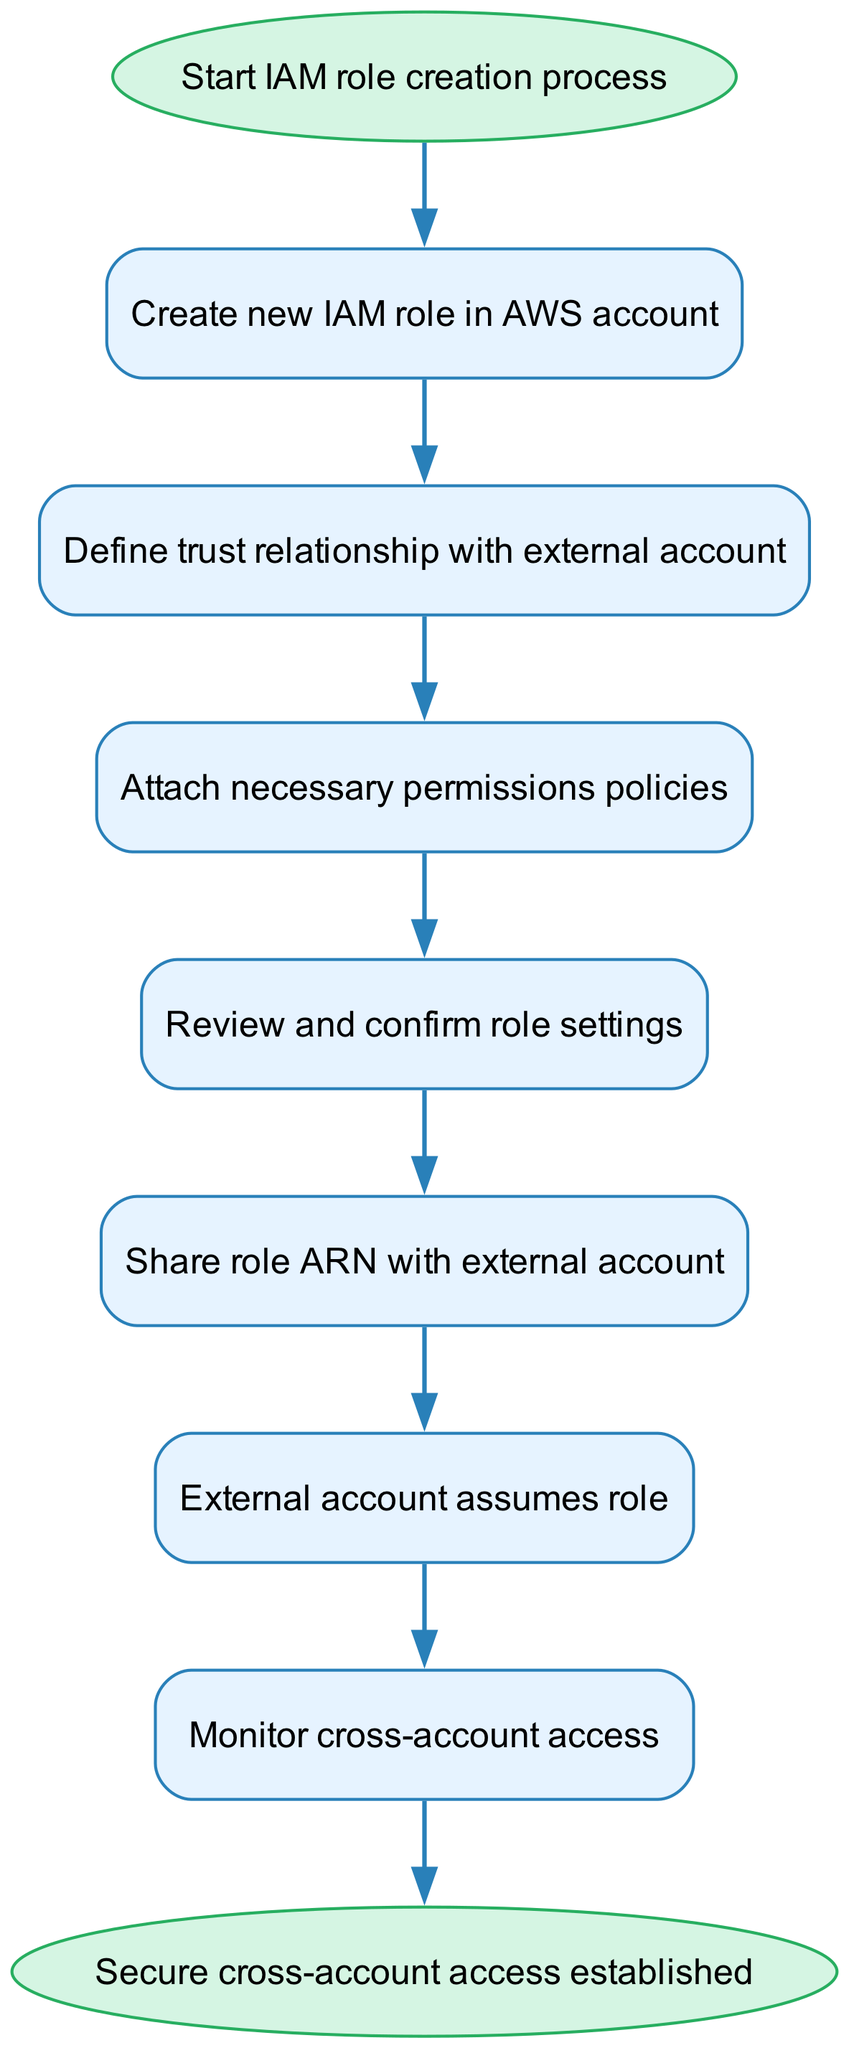What is the first step in the IAM role creation process? The first step is represented by the "Start IAM role creation process" node. It initiates the entire flow of the diagram until the last step.
Answer: Start IAM role creation process How many nodes are in this diagram? There are 9 nodes representing various steps in the IAM role creation process, including the start and end points.
Answer: 9 What step follows after attaching necessary permissions policies? The process moves to the "Review and confirm role settings" step immediately after "Attach necessary permissions policies".
Answer: Review and confirm role settings What is shared with the external account? The diagram indicates that the "role ARN" is shared with the external account after role settings have been confirmed.
Answer: role ARN Which step is completed before monitoring access? Before monitoring access, the "External account assumes role" step must be completed, indicating the external account's action in the process.
Answer: External account assumes role What is the final outcome of this process? The final outcome, as indicated in the end node, is the establishment of secure cross-account access, marking the successful completion of the IAM role creation process.
Answer: Secure cross-account access established What is the relationship between defining trust and attaching policies? The diagram shows that defining the trust relationship is a prerequisite that must happen before the necessary permissions policies can be attached.
Answer: Define trust relationship with external account How many edges connect the nodes in this diagram? There are 8 edges in total, which represent the directional flow from one node to the next in the IAM role creation process.
Answer: 8 